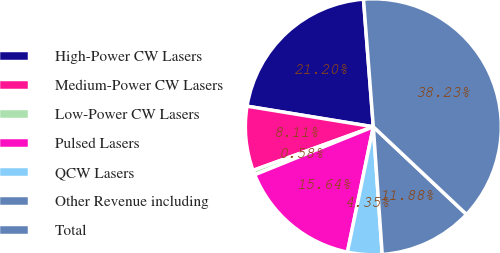Convert chart. <chart><loc_0><loc_0><loc_500><loc_500><pie_chart><fcel>High-Power CW Lasers<fcel>Medium-Power CW Lasers<fcel>Low-Power CW Lasers<fcel>Pulsed Lasers<fcel>QCW Lasers<fcel>Other Revenue including<fcel>Total<nl><fcel>21.2%<fcel>8.11%<fcel>0.58%<fcel>15.64%<fcel>4.35%<fcel>11.88%<fcel>38.23%<nl></chart> 